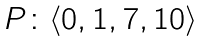<formula> <loc_0><loc_0><loc_500><loc_500>\begin{array} { c c c } P \colon \langle 0 , 1 , 7 , 1 0 \rangle \\ \end{array}</formula> 